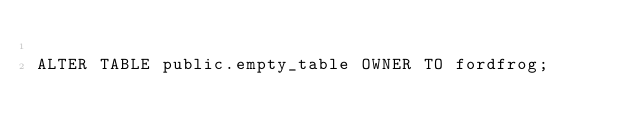Convert code to text. <code><loc_0><loc_0><loc_500><loc_500><_SQL_>
ALTER TABLE public.empty_table OWNER TO fordfrog;</code> 